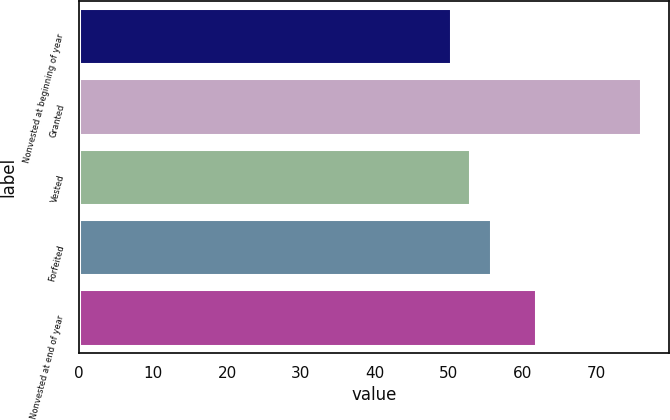<chart> <loc_0><loc_0><loc_500><loc_500><bar_chart><fcel>Nonvested at beginning of year<fcel>Granted<fcel>Vested<fcel>Forfeited<fcel>Nonvested at end of year<nl><fcel>50.3<fcel>76<fcel>52.87<fcel>55.73<fcel>61.72<nl></chart> 